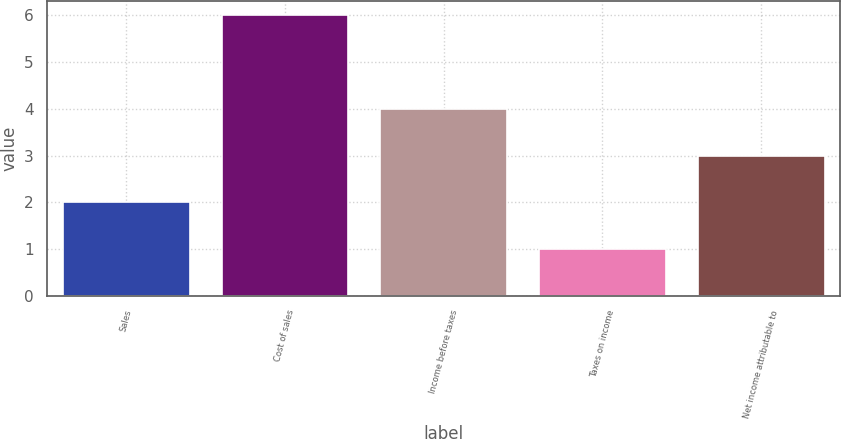Convert chart to OTSL. <chart><loc_0><loc_0><loc_500><loc_500><bar_chart><fcel>Sales<fcel>Cost of sales<fcel>Income before taxes<fcel>Taxes on income<fcel>Net income attributable to<nl><fcel>2<fcel>6<fcel>4<fcel>1<fcel>3<nl></chart> 